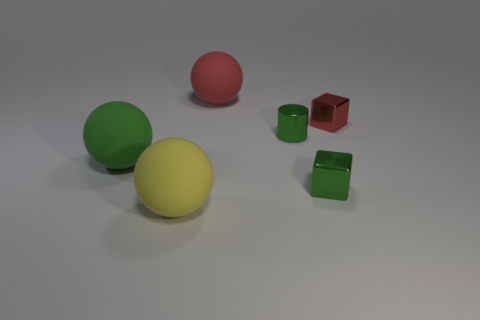Add 4 small brown metal cylinders. How many objects exist? 10 Subtract all blocks. How many objects are left? 4 Subtract all large yellow balls. Subtract all small blue matte things. How many objects are left? 5 Add 5 yellow matte things. How many yellow matte things are left? 6 Add 2 small green cylinders. How many small green cylinders exist? 3 Subtract 1 green cubes. How many objects are left? 5 